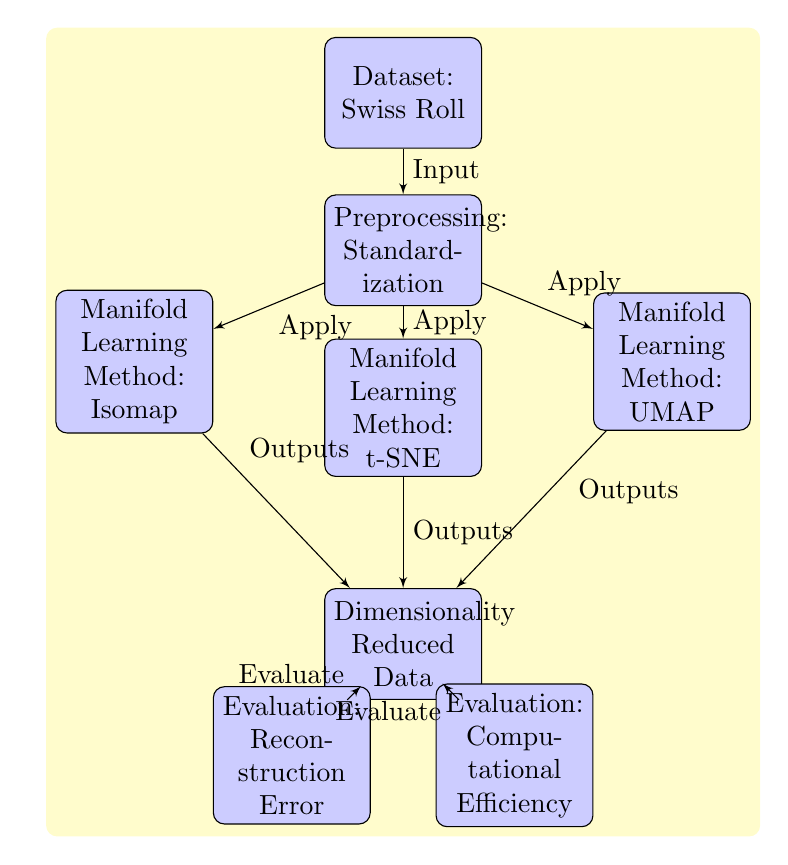What is the input to the preprocessing step? The diagram shows that the input to the preprocessing step is the "Dataset: Swiss Roll," which is linked by an arrow indicating the flow of information.
Answer: Dataset: Swiss Roll Which methods are applied after preprocessing? Three methods are highlighted in the diagram as being applied after preprocessing, which are Isomap, t-SNE, and UMAP, all connected to the preprocessing block with arrows.
Answer: Isomap, t-SNE, UMAP What is the evaluation criteria used after the dimensionality reduction? The diagram shows two evaluation criteria emerging from the "Dimensionality Reduced Data" node, which are "Reconstruction Error" and "Computational Efficiency."
Answer: Reconstruction Error, Computational Efficiency How many total blocks are present in the diagram? The diagram contains seven blocks in total: the dataset, preprocessing, three manifold learning methods, the reduced data, and two evaluation criteria, which can be counted directly.
Answer: Seven What is the relationship between the preprocessing and the manifold learning methods? The relationship is that preprocessing is necessary before any of the manifold learning methods are applied, as indicated by the arrows that flow from the preprocessing block to each of the method blocks.
Answer: Necessary prerequisite Which manifold learning method outputs directly to the reduced data? The diagram indicates that all three methods (Isomap, t-SNE, and UMAP) output directly to the "Dimensionality Reduced Data," as each of these methods has an arrow leading to that block.
Answer: Isomap, t-SNE, UMAP Which evaluation focuses on how well the data structure has been preserved? The "Reconstruction Error" evaluation is concerned with assessing how accurately the original structure of the data can be reconstructed after dimensionality reduction, as indicated directly above the arrow to that evaluation block.
Answer: Reconstruction Error What color represents the blocks in the diagram? The blocks in the diagram are filled with a light blue color, which is specified by the fill attribute in the TikZ style for blocks.
Answer: Light blue 